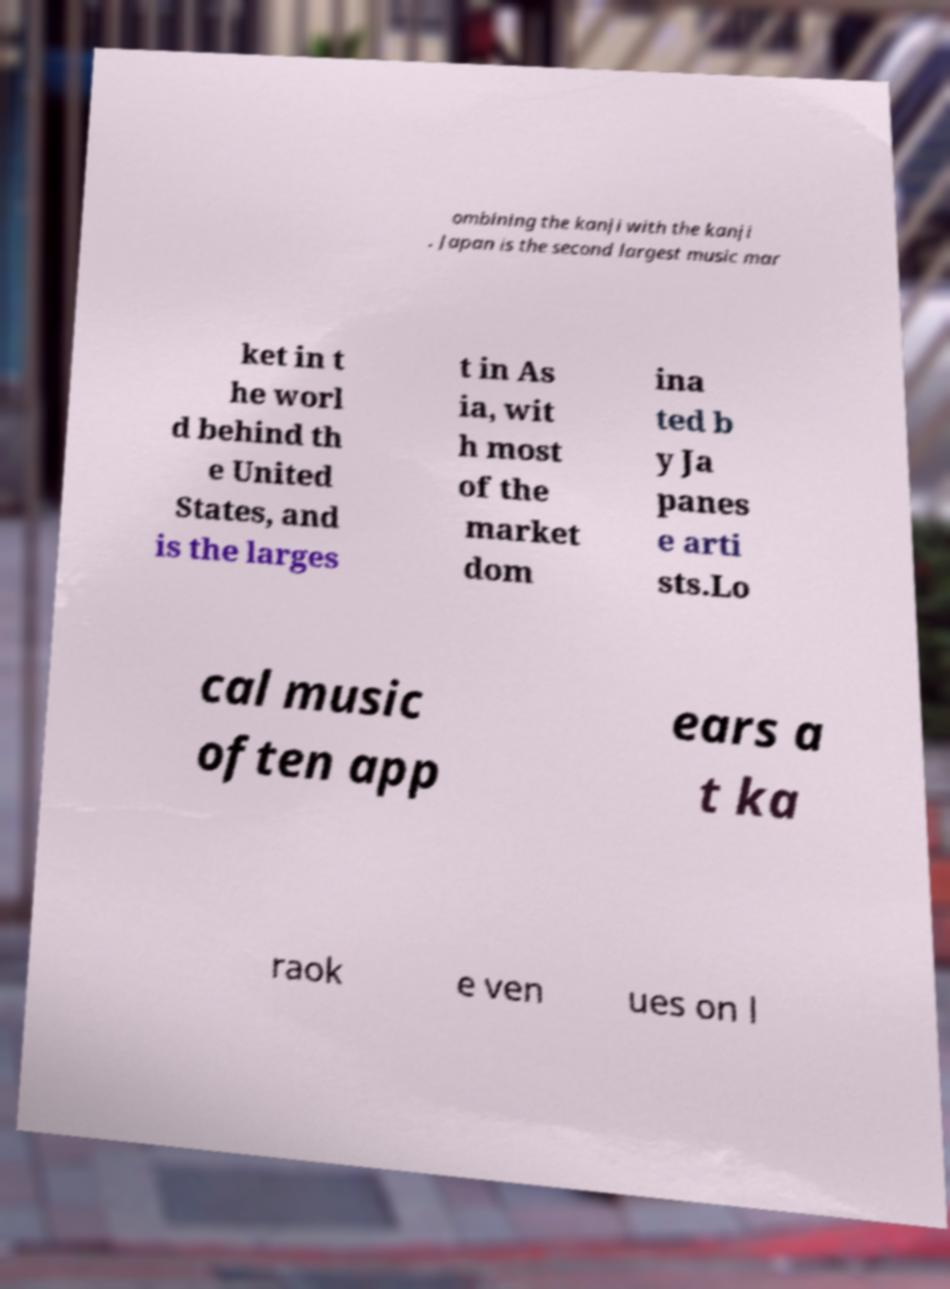There's text embedded in this image that I need extracted. Can you transcribe it verbatim? ombining the kanji with the kanji . Japan is the second largest music mar ket in t he worl d behind th e United States, and is the larges t in As ia, wit h most of the market dom ina ted b y Ja panes e arti sts.Lo cal music often app ears a t ka raok e ven ues on l 